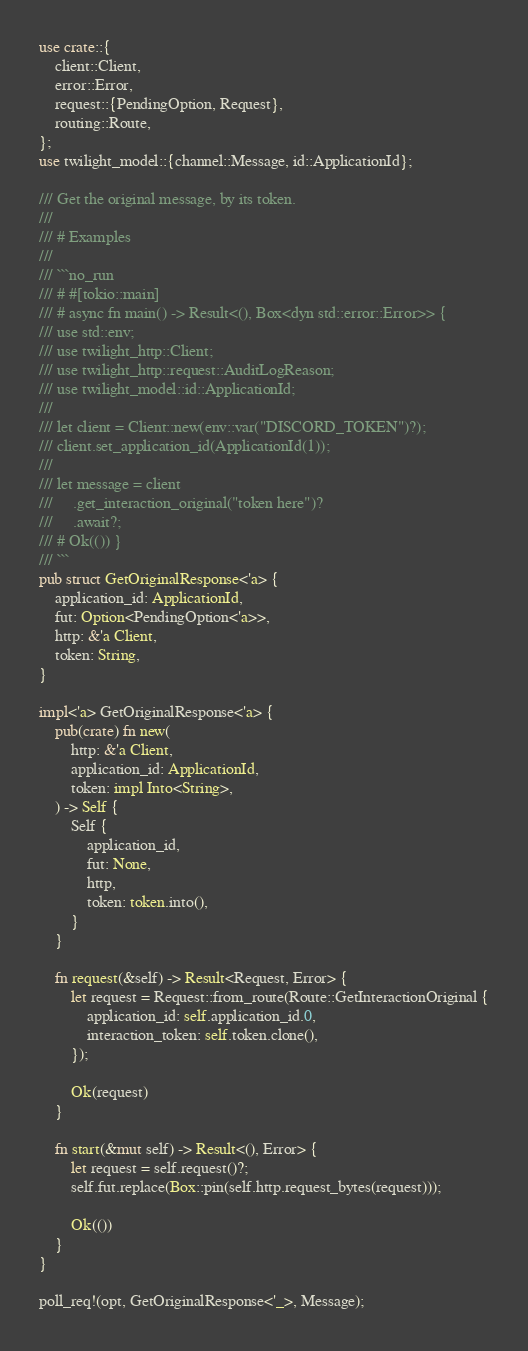<code> <loc_0><loc_0><loc_500><loc_500><_Rust_>use crate::{
    client::Client,
    error::Error,
    request::{PendingOption, Request},
    routing::Route,
};
use twilight_model::{channel::Message, id::ApplicationId};

/// Get the original message, by its token.
///
/// # Examples
///
/// ```no_run
/// # #[tokio::main]
/// # async fn main() -> Result<(), Box<dyn std::error::Error>> {
/// use std::env;
/// use twilight_http::Client;
/// use twilight_http::request::AuditLogReason;
/// use twilight_model::id::ApplicationId;
///
/// let client = Client::new(env::var("DISCORD_TOKEN")?);
/// client.set_application_id(ApplicationId(1));
///
/// let message = client
///     .get_interaction_original("token here")?
///     .await?;
/// # Ok(()) }
/// ```
pub struct GetOriginalResponse<'a> {
    application_id: ApplicationId,
    fut: Option<PendingOption<'a>>,
    http: &'a Client,
    token: String,
}

impl<'a> GetOriginalResponse<'a> {
    pub(crate) fn new(
        http: &'a Client,
        application_id: ApplicationId,
        token: impl Into<String>,
    ) -> Self {
        Self {
            application_id,
            fut: None,
            http,
            token: token.into(),
        }
    }

    fn request(&self) -> Result<Request, Error> {
        let request = Request::from_route(Route::GetInteractionOriginal {
            application_id: self.application_id.0,
            interaction_token: self.token.clone(),
        });

        Ok(request)
    }

    fn start(&mut self) -> Result<(), Error> {
        let request = self.request()?;
        self.fut.replace(Box::pin(self.http.request_bytes(request)));

        Ok(())
    }
}

poll_req!(opt, GetOriginalResponse<'_>, Message);
</code> 